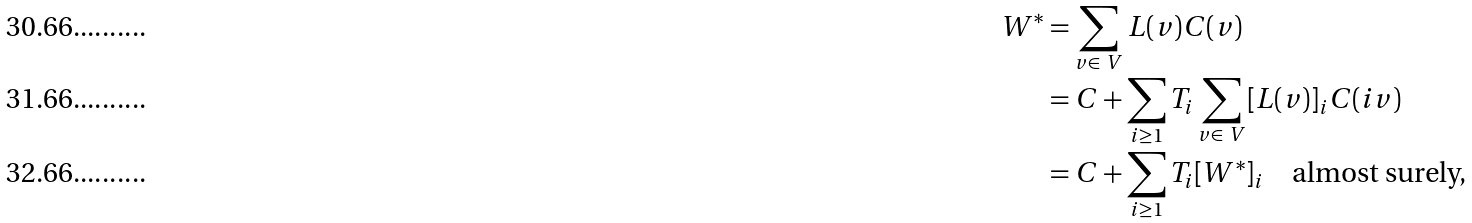Convert formula to latex. <formula><loc_0><loc_0><loc_500><loc_500>W ^ { * } & = \sum _ { v \in \ V } L ( v ) C ( v ) \\ & = C + \sum _ { i \geq 1 } T _ { i } \sum _ { v \in \ V } [ L ( v ) ] _ { i } C ( i v ) \\ & = C + \sum _ { i \geq 1 } T _ { i } [ W ^ { * } ] _ { i } \quad \text {almost surely,}</formula> 